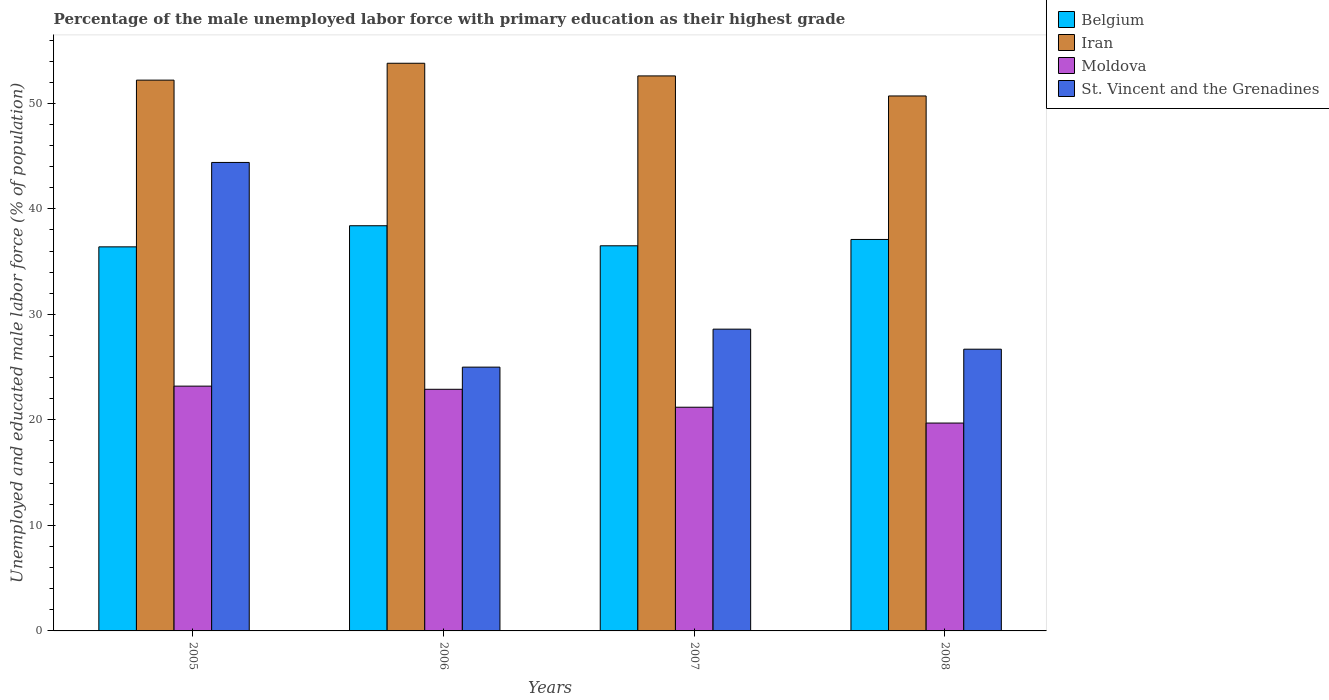How many groups of bars are there?
Provide a short and direct response. 4. How many bars are there on the 4th tick from the right?
Provide a short and direct response. 4. What is the label of the 4th group of bars from the left?
Your answer should be compact. 2008. What is the percentage of the unemployed male labor force with primary education in Moldova in 2007?
Give a very brief answer. 21.2. Across all years, what is the maximum percentage of the unemployed male labor force with primary education in Belgium?
Keep it short and to the point. 38.4. Across all years, what is the minimum percentage of the unemployed male labor force with primary education in Iran?
Give a very brief answer. 50.7. In which year was the percentage of the unemployed male labor force with primary education in Belgium minimum?
Provide a succinct answer. 2005. What is the total percentage of the unemployed male labor force with primary education in St. Vincent and the Grenadines in the graph?
Your answer should be compact. 124.7. What is the difference between the percentage of the unemployed male labor force with primary education in St. Vincent and the Grenadines in 2005 and that in 2006?
Provide a succinct answer. 19.4. What is the difference between the percentage of the unemployed male labor force with primary education in Moldova in 2008 and the percentage of the unemployed male labor force with primary education in St. Vincent and the Grenadines in 2005?
Provide a short and direct response. -24.7. What is the average percentage of the unemployed male labor force with primary education in St. Vincent and the Grenadines per year?
Make the answer very short. 31.18. In the year 2007, what is the difference between the percentage of the unemployed male labor force with primary education in Moldova and percentage of the unemployed male labor force with primary education in Iran?
Offer a terse response. -31.4. What is the ratio of the percentage of the unemployed male labor force with primary education in Iran in 2005 to that in 2007?
Give a very brief answer. 0.99. Is the percentage of the unemployed male labor force with primary education in St. Vincent and the Grenadines in 2005 less than that in 2006?
Make the answer very short. No. Is the difference between the percentage of the unemployed male labor force with primary education in Moldova in 2005 and 2007 greater than the difference between the percentage of the unemployed male labor force with primary education in Iran in 2005 and 2007?
Make the answer very short. Yes. What is the difference between the highest and the second highest percentage of the unemployed male labor force with primary education in Belgium?
Keep it short and to the point. 1.3. What is the difference between the highest and the lowest percentage of the unemployed male labor force with primary education in St. Vincent and the Grenadines?
Keep it short and to the point. 19.4. In how many years, is the percentage of the unemployed male labor force with primary education in Iran greater than the average percentage of the unemployed male labor force with primary education in Iran taken over all years?
Keep it short and to the point. 2. Is the sum of the percentage of the unemployed male labor force with primary education in Belgium in 2005 and 2006 greater than the maximum percentage of the unemployed male labor force with primary education in St. Vincent and the Grenadines across all years?
Provide a succinct answer. Yes. Is it the case that in every year, the sum of the percentage of the unemployed male labor force with primary education in Iran and percentage of the unemployed male labor force with primary education in St. Vincent and the Grenadines is greater than the sum of percentage of the unemployed male labor force with primary education in Moldova and percentage of the unemployed male labor force with primary education in Belgium?
Give a very brief answer. No. What does the 3rd bar from the left in 2008 represents?
Your answer should be compact. Moldova. What does the 2nd bar from the right in 2005 represents?
Your response must be concise. Moldova. Is it the case that in every year, the sum of the percentage of the unemployed male labor force with primary education in Iran and percentage of the unemployed male labor force with primary education in Moldova is greater than the percentage of the unemployed male labor force with primary education in Belgium?
Provide a succinct answer. Yes. How many years are there in the graph?
Give a very brief answer. 4. What is the difference between two consecutive major ticks on the Y-axis?
Ensure brevity in your answer.  10. Are the values on the major ticks of Y-axis written in scientific E-notation?
Make the answer very short. No. Does the graph contain any zero values?
Offer a terse response. No. Where does the legend appear in the graph?
Offer a very short reply. Top right. How many legend labels are there?
Provide a short and direct response. 4. How are the legend labels stacked?
Provide a succinct answer. Vertical. What is the title of the graph?
Make the answer very short. Percentage of the male unemployed labor force with primary education as their highest grade. What is the label or title of the X-axis?
Ensure brevity in your answer.  Years. What is the label or title of the Y-axis?
Your answer should be compact. Unemployed and educated male labor force (% of population). What is the Unemployed and educated male labor force (% of population) in Belgium in 2005?
Provide a short and direct response. 36.4. What is the Unemployed and educated male labor force (% of population) in Iran in 2005?
Give a very brief answer. 52.2. What is the Unemployed and educated male labor force (% of population) in Moldova in 2005?
Give a very brief answer. 23.2. What is the Unemployed and educated male labor force (% of population) in St. Vincent and the Grenadines in 2005?
Your answer should be compact. 44.4. What is the Unemployed and educated male labor force (% of population) in Belgium in 2006?
Offer a terse response. 38.4. What is the Unemployed and educated male labor force (% of population) of Iran in 2006?
Make the answer very short. 53.8. What is the Unemployed and educated male labor force (% of population) in Moldova in 2006?
Your response must be concise. 22.9. What is the Unemployed and educated male labor force (% of population) of St. Vincent and the Grenadines in 2006?
Your answer should be very brief. 25. What is the Unemployed and educated male labor force (% of population) of Belgium in 2007?
Your response must be concise. 36.5. What is the Unemployed and educated male labor force (% of population) in Iran in 2007?
Offer a terse response. 52.6. What is the Unemployed and educated male labor force (% of population) of Moldova in 2007?
Provide a succinct answer. 21.2. What is the Unemployed and educated male labor force (% of population) of St. Vincent and the Grenadines in 2007?
Offer a terse response. 28.6. What is the Unemployed and educated male labor force (% of population) in Belgium in 2008?
Your answer should be compact. 37.1. What is the Unemployed and educated male labor force (% of population) in Iran in 2008?
Offer a terse response. 50.7. What is the Unemployed and educated male labor force (% of population) in Moldova in 2008?
Offer a very short reply. 19.7. What is the Unemployed and educated male labor force (% of population) of St. Vincent and the Grenadines in 2008?
Give a very brief answer. 26.7. Across all years, what is the maximum Unemployed and educated male labor force (% of population) of Belgium?
Give a very brief answer. 38.4. Across all years, what is the maximum Unemployed and educated male labor force (% of population) of Iran?
Your response must be concise. 53.8. Across all years, what is the maximum Unemployed and educated male labor force (% of population) of Moldova?
Your answer should be compact. 23.2. Across all years, what is the maximum Unemployed and educated male labor force (% of population) in St. Vincent and the Grenadines?
Offer a very short reply. 44.4. Across all years, what is the minimum Unemployed and educated male labor force (% of population) in Belgium?
Your answer should be very brief. 36.4. Across all years, what is the minimum Unemployed and educated male labor force (% of population) of Iran?
Your answer should be compact. 50.7. Across all years, what is the minimum Unemployed and educated male labor force (% of population) of Moldova?
Offer a very short reply. 19.7. What is the total Unemployed and educated male labor force (% of population) of Belgium in the graph?
Keep it short and to the point. 148.4. What is the total Unemployed and educated male labor force (% of population) of Iran in the graph?
Provide a short and direct response. 209.3. What is the total Unemployed and educated male labor force (% of population) in St. Vincent and the Grenadines in the graph?
Your answer should be very brief. 124.7. What is the difference between the Unemployed and educated male labor force (% of population) of Belgium in 2005 and that in 2006?
Give a very brief answer. -2. What is the difference between the Unemployed and educated male labor force (% of population) in Iran in 2005 and that in 2006?
Provide a short and direct response. -1.6. What is the difference between the Unemployed and educated male labor force (% of population) in Moldova in 2005 and that in 2006?
Ensure brevity in your answer.  0.3. What is the difference between the Unemployed and educated male labor force (% of population) of St. Vincent and the Grenadines in 2005 and that in 2006?
Give a very brief answer. 19.4. What is the difference between the Unemployed and educated male labor force (% of population) in Iran in 2005 and that in 2007?
Offer a very short reply. -0.4. What is the difference between the Unemployed and educated male labor force (% of population) of Moldova in 2005 and that in 2007?
Provide a succinct answer. 2. What is the difference between the Unemployed and educated male labor force (% of population) of Iran in 2005 and that in 2008?
Your answer should be compact. 1.5. What is the difference between the Unemployed and educated male labor force (% of population) of Belgium in 2006 and that in 2007?
Offer a terse response. 1.9. What is the difference between the Unemployed and educated male labor force (% of population) in Iran in 2006 and that in 2007?
Give a very brief answer. 1.2. What is the difference between the Unemployed and educated male labor force (% of population) of Moldova in 2006 and that in 2007?
Provide a succinct answer. 1.7. What is the difference between the Unemployed and educated male labor force (% of population) in Belgium in 2006 and that in 2008?
Keep it short and to the point. 1.3. What is the difference between the Unemployed and educated male labor force (% of population) of Moldova in 2006 and that in 2008?
Your answer should be compact. 3.2. What is the difference between the Unemployed and educated male labor force (% of population) of Belgium in 2007 and that in 2008?
Offer a terse response. -0.6. What is the difference between the Unemployed and educated male labor force (% of population) in St. Vincent and the Grenadines in 2007 and that in 2008?
Ensure brevity in your answer.  1.9. What is the difference between the Unemployed and educated male labor force (% of population) in Belgium in 2005 and the Unemployed and educated male labor force (% of population) in Iran in 2006?
Offer a terse response. -17.4. What is the difference between the Unemployed and educated male labor force (% of population) of Belgium in 2005 and the Unemployed and educated male labor force (% of population) of St. Vincent and the Grenadines in 2006?
Provide a short and direct response. 11.4. What is the difference between the Unemployed and educated male labor force (% of population) in Iran in 2005 and the Unemployed and educated male labor force (% of population) in Moldova in 2006?
Keep it short and to the point. 29.3. What is the difference between the Unemployed and educated male labor force (% of population) in Iran in 2005 and the Unemployed and educated male labor force (% of population) in St. Vincent and the Grenadines in 2006?
Your response must be concise. 27.2. What is the difference between the Unemployed and educated male labor force (% of population) in Moldova in 2005 and the Unemployed and educated male labor force (% of population) in St. Vincent and the Grenadines in 2006?
Ensure brevity in your answer.  -1.8. What is the difference between the Unemployed and educated male labor force (% of population) of Belgium in 2005 and the Unemployed and educated male labor force (% of population) of Iran in 2007?
Ensure brevity in your answer.  -16.2. What is the difference between the Unemployed and educated male labor force (% of population) of Belgium in 2005 and the Unemployed and educated male labor force (% of population) of Moldova in 2007?
Provide a short and direct response. 15.2. What is the difference between the Unemployed and educated male labor force (% of population) of Belgium in 2005 and the Unemployed and educated male labor force (% of population) of St. Vincent and the Grenadines in 2007?
Your answer should be compact. 7.8. What is the difference between the Unemployed and educated male labor force (% of population) of Iran in 2005 and the Unemployed and educated male labor force (% of population) of St. Vincent and the Grenadines in 2007?
Offer a very short reply. 23.6. What is the difference between the Unemployed and educated male labor force (% of population) of Belgium in 2005 and the Unemployed and educated male labor force (% of population) of Iran in 2008?
Provide a short and direct response. -14.3. What is the difference between the Unemployed and educated male labor force (% of population) of Belgium in 2005 and the Unemployed and educated male labor force (% of population) of Moldova in 2008?
Ensure brevity in your answer.  16.7. What is the difference between the Unemployed and educated male labor force (% of population) in Iran in 2005 and the Unemployed and educated male labor force (% of population) in Moldova in 2008?
Make the answer very short. 32.5. What is the difference between the Unemployed and educated male labor force (% of population) in Moldova in 2005 and the Unemployed and educated male labor force (% of population) in St. Vincent and the Grenadines in 2008?
Your answer should be compact. -3.5. What is the difference between the Unemployed and educated male labor force (% of population) in Belgium in 2006 and the Unemployed and educated male labor force (% of population) in Iran in 2007?
Ensure brevity in your answer.  -14.2. What is the difference between the Unemployed and educated male labor force (% of population) in Belgium in 2006 and the Unemployed and educated male labor force (% of population) in St. Vincent and the Grenadines in 2007?
Offer a very short reply. 9.8. What is the difference between the Unemployed and educated male labor force (% of population) in Iran in 2006 and the Unemployed and educated male labor force (% of population) in Moldova in 2007?
Keep it short and to the point. 32.6. What is the difference between the Unemployed and educated male labor force (% of population) of Iran in 2006 and the Unemployed and educated male labor force (% of population) of St. Vincent and the Grenadines in 2007?
Make the answer very short. 25.2. What is the difference between the Unemployed and educated male labor force (% of population) in Belgium in 2006 and the Unemployed and educated male labor force (% of population) in Iran in 2008?
Ensure brevity in your answer.  -12.3. What is the difference between the Unemployed and educated male labor force (% of population) of Iran in 2006 and the Unemployed and educated male labor force (% of population) of Moldova in 2008?
Offer a very short reply. 34.1. What is the difference between the Unemployed and educated male labor force (% of population) in Iran in 2006 and the Unemployed and educated male labor force (% of population) in St. Vincent and the Grenadines in 2008?
Make the answer very short. 27.1. What is the difference between the Unemployed and educated male labor force (% of population) of Moldova in 2006 and the Unemployed and educated male labor force (% of population) of St. Vincent and the Grenadines in 2008?
Your response must be concise. -3.8. What is the difference between the Unemployed and educated male labor force (% of population) in Iran in 2007 and the Unemployed and educated male labor force (% of population) in Moldova in 2008?
Ensure brevity in your answer.  32.9. What is the difference between the Unemployed and educated male labor force (% of population) in Iran in 2007 and the Unemployed and educated male labor force (% of population) in St. Vincent and the Grenadines in 2008?
Provide a succinct answer. 25.9. What is the average Unemployed and educated male labor force (% of population) of Belgium per year?
Offer a very short reply. 37.1. What is the average Unemployed and educated male labor force (% of population) in Iran per year?
Your answer should be very brief. 52.33. What is the average Unemployed and educated male labor force (% of population) in Moldova per year?
Offer a very short reply. 21.75. What is the average Unemployed and educated male labor force (% of population) of St. Vincent and the Grenadines per year?
Make the answer very short. 31.18. In the year 2005, what is the difference between the Unemployed and educated male labor force (% of population) in Belgium and Unemployed and educated male labor force (% of population) in Iran?
Provide a succinct answer. -15.8. In the year 2005, what is the difference between the Unemployed and educated male labor force (% of population) in Belgium and Unemployed and educated male labor force (% of population) in St. Vincent and the Grenadines?
Your answer should be compact. -8. In the year 2005, what is the difference between the Unemployed and educated male labor force (% of population) in Iran and Unemployed and educated male labor force (% of population) in Moldova?
Ensure brevity in your answer.  29. In the year 2005, what is the difference between the Unemployed and educated male labor force (% of population) in Moldova and Unemployed and educated male labor force (% of population) in St. Vincent and the Grenadines?
Offer a terse response. -21.2. In the year 2006, what is the difference between the Unemployed and educated male labor force (% of population) in Belgium and Unemployed and educated male labor force (% of population) in Iran?
Your answer should be very brief. -15.4. In the year 2006, what is the difference between the Unemployed and educated male labor force (% of population) of Belgium and Unemployed and educated male labor force (% of population) of St. Vincent and the Grenadines?
Provide a short and direct response. 13.4. In the year 2006, what is the difference between the Unemployed and educated male labor force (% of population) in Iran and Unemployed and educated male labor force (% of population) in Moldova?
Make the answer very short. 30.9. In the year 2006, what is the difference between the Unemployed and educated male labor force (% of population) of Iran and Unemployed and educated male labor force (% of population) of St. Vincent and the Grenadines?
Your answer should be compact. 28.8. In the year 2007, what is the difference between the Unemployed and educated male labor force (% of population) of Belgium and Unemployed and educated male labor force (% of population) of Iran?
Give a very brief answer. -16.1. In the year 2007, what is the difference between the Unemployed and educated male labor force (% of population) in Belgium and Unemployed and educated male labor force (% of population) in Moldova?
Your answer should be compact. 15.3. In the year 2007, what is the difference between the Unemployed and educated male labor force (% of population) in Iran and Unemployed and educated male labor force (% of population) in Moldova?
Make the answer very short. 31.4. In the year 2008, what is the difference between the Unemployed and educated male labor force (% of population) of Belgium and Unemployed and educated male labor force (% of population) of Iran?
Your answer should be very brief. -13.6. In the year 2008, what is the difference between the Unemployed and educated male labor force (% of population) in Iran and Unemployed and educated male labor force (% of population) in St. Vincent and the Grenadines?
Your answer should be very brief. 24. In the year 2008, what is the difference between the Unemployed and educated male labor force (% of population) of Moldova and Unemployed and educated male labor force (% of population) of St. Vincent and the Grenadines?
Ensure brevity in your answer.  -7. What is the ratio of the Unemployed and educated male labor force (% of population) in Belgium in 2005 to that in 2006?
Give a very brief answer. 0.95. What is the ratio of the Unemployed and educated male labor force (% of population) in Iran in 2005 to that in 2006?
Offer a terse response. 0.97. What is the ratio of the Unemployed and educated male labor force (% of population) in Moldova in 2005 to that in 2006?
Make the answer very short. 1.01. What is the ratio of the Unemployed and educated male labor force (% of population) in St. Vincent and the Grenadines in 2005 to that in 2006?
Offer a very short reply. 1.78. What is the ratio of the Unemployed and educated male labor force (% of population) in Belgium in 2005 to that in 2007?
Give a very brief answer. 1. What is the ratio of the Unemployed and educated male labor force (% of population) of Moldova in 2005 to that in 2007?
Your response must be concise. 1.09. What is the ratio of the Unemployed and educated male labor force (% of population) in St. Vincent and the Grenadines in 2005 to that in 2007?
Your answer should be very brief. 1.55. What is the ratio of the Unemployed and educated male labor force (% of population) in Belgium in 2005 to that in 2008?
Your answer should be very brief. 0.98. What is the ratio of the Unemployed and educated male labor force (% of population) in Iran in 2005 to that in 2008?
Keep it short and to the point. 1.03. What is the ratio of the Unemployed and educated male labor force (% of population) of Moldova in 2005 to that in 2008?
Offer a very short reply. 1.18. What is the ratio of the Unemployed and educated male labor force (% of population) of St. Vincent and the Grenadines in 2005 to that in 2008?
Give a very brief answer. 1.66. What is the ratio of the Unemployed and educated male labor force (% of population) in Belgium in 2006 to that in 2007?
Keep it short and to the point. 1.05. What is the ratio of the Unemployed and educated male labor force (% of population) in Iran in 2006 to that in 2007?
Ensure brevity in your answer.  1.02. What is the ratio of the Unemployed and educated male labor force (% of population) in Moldova in 2006 to that in 2007?
Keep it short and to the point. 1.08. What is the ratio of the Unemployed and educated male labor force (% of population) of St. Vincent and the Grenadines in 2006 to that in 2007?
Your answer should be very brief. 0.87. What is the ratio of the Unemployed and educated male labor force (% of population) of Belgium in 2006 to that in 2008?
Keep it short and to the point. 1.03. What is the ratio of the Unemployed and educated male labor force (% of population) in Iran in 2006 to that in 2008?
Make the answer very short. 1.06. What is the ratio of the Unemployed and educated male labor force (% of population) in Moldova in 2006 to that in 2008?
Give a very brief answer. 1.16. What is the ratio of the Unemployed and educated male labor force (% of population) of St. Vincent and the Grenadines in 2006 to that in 2008?
Ensure brevity in your answer.  0.94. What is the ratio of the Unemployed and educated male labor force (% of population) of Belgium in 2007 to that in 2008?
Provide a short and direct response. 0.98. What is the ratio of the Unemployed and educated male labor force (% of population) of Iran in 2007 to that in 2008?
Make the answer very short. 1.04. What is the ratio of the Unemployed and educated male labor force (% of population) of Moldova in 2007 to that in 2008?
Provide a short and direct response. 1.08. What is the ratio of the Unemployed and educated male labor force (% of population) of St. Vincent and the Grenadines in 2007 to that in 2008?
Your answer should be very brief. 1.07. What is the difference between the highest and the second highest Unemployed and educated male labor force (% of population) in Belgium?
Your answer should be compact. 1.3. What is the difference between the highest and the lowest Unemployed and educated male labor force (% of population) of Belgium?
Offer a very short reply. 2. What is the difference between the highest and the lowest Unemployed and educated male labor force (% of population) of St. Vincent and the Grenadines?
Make the answer very short. 19.4. 